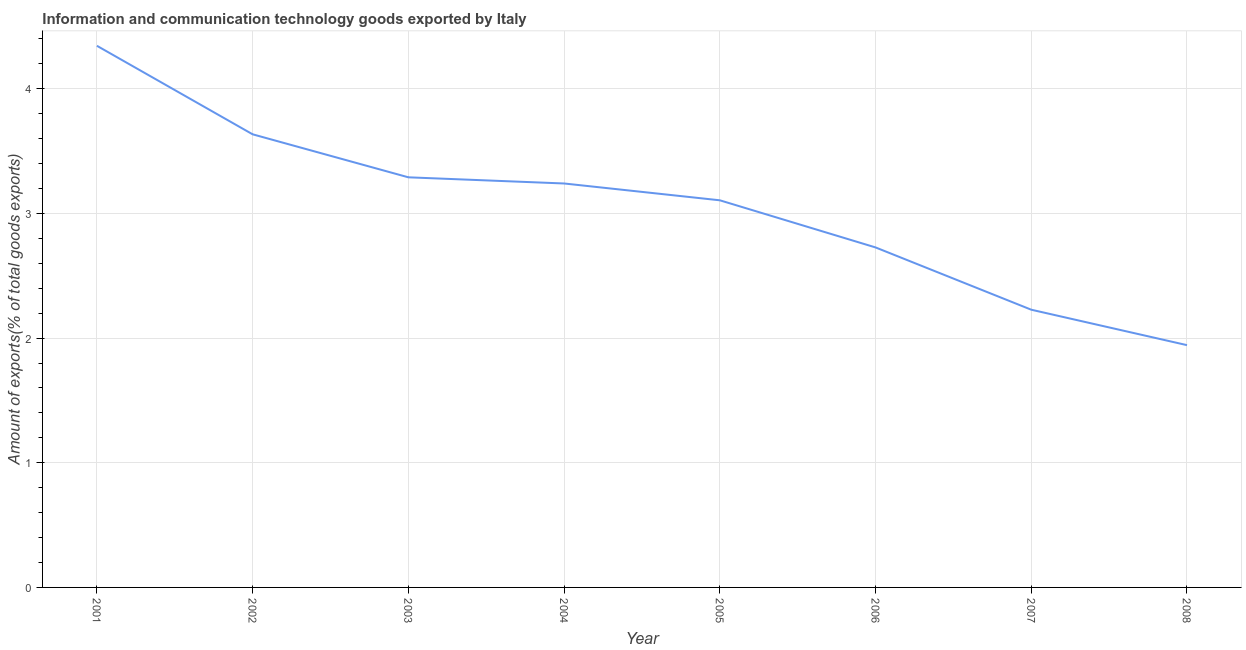What is the amount of ict goods exports in 2002?
Your answer should be very brief. 3.63. Across all years, what is the maximum amount of ict goods exports?
Your response must be concise. 4.34. Across all years, what is the minimum amount of ict goods exports?
Offer a very short reply. 1.94. In which year was the amount of ict goods exports minimum?
Offer a terse response. 2008. What is the sum of the amount of ict goods exports?
Offer a very short reply. 24.51. What is the difference between the amount of ict goods exports in 2003 and 2005?
Offer a very short reply. 0.18. What is the average amount of ict goods exports per year?
Ensure brevity in your answer.  3.06. What is the median amount of ict goods exports?
Keep it short and to the point. 3.17. What is the ratio of the amount of ict goods exports in 2005 to that in 2007?
Make the answer very short. 1.39. What is the difference between the highest and the second highest amount of ict goods exports?
Ensure brevity in your answer.  0.71. What is the difference between the highest and the lowest amount of ict goods exports?
Your answer should be compact. 2.4. In how many years, is the amount of ict goods exports greater than the average amount of ict goods exports taken over all years?
Make the answer very short. 5. How many lines are there?
Give a very brief answer. 1. How many years are there in the graph?
Your answer should be compact. 8. Does the graph contain any zero values?
Your answer should be very brief. No. What is the title of the graph?
Offer a very short reply. Information and communication technology goods exported by Italy. What is the label or title of the Y-axis?
Keep it short and to the point. Amount of exports(% of total goods exports). What is the Amount of exports(% of total goods exports) in 2001?
Keep it short and to the point. 4.34. What is the Amount of exports(% of total goods exports) in 2002?
Keep it short and to the point. 3.63. What is the Amount of exports(% of total goods exports) in 2003?
Offer a terse response. 3.29. What is the Amount of exports(% of total goods exports) in 2004?
Keep it short and to the point. 3.24. What is the Amount of exports(% of total goods exports) in 2005?
Ensure brevity in your answer.  3.11. What is the Amount of exports(% of total goods exports) of 2006?
Provide a short and direct response. 2.73. What is the Amount of exports(% of total goods exports) of 2007?
Provide a short and direct response. 2.23. What is the Amount of exports(% of total goods exports) in 2008?
Keep it short and to the point. 1.94. What is the difference between the Amount of exports(% of total goods exports) in 2001 and 2002?
Offer a terse response. 0.71. What is the difference between the Amount of exports(% of total goods exports) in 2001 and 2003?
Make the answer very short. 1.05. What is the difference between the Amount of exports(% of total goods exports) in 2001 and 2004?
Ensure brevity in your answer.  1.1. What is the difference between the Amount of exports(% of total goods exports) in 2001 and 2005?
Offer a terse response. 1.24. What is the difference between the Amount of exports(% of total goods exports) in 2001 and 2006?
Your answer should be compact. 1.62. What is the difference between the Amount of exports(% of total goods exports) in 2001 and 2007?
Offer a very short reply. 2.12. What is the difference between the Amount of exports(% of total goods exports) in 2001 and 2008?
Your answer should be very brief. 2.4. What is the difference between the Amount of exports(% of total goods exports) in 2002 and 2003?
Offer a terse response. 0.34. What is the difference between the Amount of exports(% of total goods exports) in 2002 and 2004?
Your answer should be compact. 0.39. What is the difference between the Amount of exports(% of total goods exports) in 2002 and 2005?
Offer a very short reply. 0.53. What is the difference between the Amount of exports(% of total goods exports) in 2002 and 2006?
Provide a short and direct response. 0.91. What is the difference between the Amount of exports(% of total goods exports) in 2002 and 2007?
Keep it short and to the point. 1.41. What is the difference between the Amount of exports(% of total goods exports) in 2002 and 2008?
Make the answer very short. 1.69. What is the difference between the Amount of exports(% of total goods exports) in 2003 and 2004?
Give a very brief answer. 0.05. What is the difference between the Amount of exports(% of total goods exports) in 2003 and 2005?
Ensure brevity in your answer.  0.18. What is the difference between the Amount of exports(% of total goods exports) in 2003 and 2006?
Your answer should be very brief. 0.56. What is the difference between the Amount of exports(% of total goods exports) in 2003 and 2007?
Provide a short and direct response. 1.06. What is the difference between the Amount of exports(% of total goods exports) in 2003 and 2008?
Your answer should be compact. 1.35. What is the difference between the Amount of exports(% of total goods exports) in 2004 and 2005?
Make the answer very short. 0.13. What is the difference between the Amount of exports(% of total goods exports) in 2004 and 2006?
Ensure brevity in your answer.  0.51. What is the difference between the Amount of exports(% of total goods exports) in 2004 and 2007?
Provide a succinct answer. 1.01. What is the difference between the Amount of exports(% of total goods exports) in 2004 and 2008?
Your response must be concise. 1.3. What is the difference between the Amount of exports(% of total goods exports) in 2005 and 2006?
Ensure brevity in your answer.  0.38. What is the difference between the Amount of exports(% of total goods exports) in 2005 and 2007?
Offer a terse response. 0.88. What is the difference between the Amount of exports(% of total goods exports) in 2005 and 2008?
Offer a terse response. 1.16. What is the difference between the Amount of exports(% of total goods exports) in 2006 and 2007?
Offer a very short reply. 0.5. What is the difference between the Amount of exports(% of total goods exports) in 2006 and 2008?
Provide a succinct answer. 0.78. What is the difference between the Amount of exports(% of total goods exports) in 2007 and 2008?
Offer a terse response. 0.28. What is the ratio of the Amount of exports(% of total goods exports) in 2001 to that in 2002?
Offer a terse response. 1.2. What is the ratio of the Amount of exports(% of total goods exports) in 2001 to that in 2003?
Make the answer very short. 1.32. What is the ratio of the Amount of exports(% of total goods exports) in 2001 to that in 2004?
Ensure brevity in your answer.  1.34. What is the ratio of the Amount of exports(% of total goods exports) in 2001 to that in 2005?
Your answer should be compact. 1.4. What is the ratio of the Amount of exports(% of total goods exports) in 2001 to that in 2006?
Offer a terse response. 1.59. What is the ratio of the Amount of exports(% of total goods exports) in 2001 to that in 2007?
Make the answer very short. 1.95. What is the ratio of the Amount of exports(% of total goods exports) in 2001 to that in 2008?
Ensure brevity in your answer.  2.24. What is the ratio of the Amount of exports(% of total goods exports) in 2002 to that in 2003?
Keep it short and to the point. 1.1. What is the ratio of the Amount of exports(% of total goods exports) in 2002 to that in 2004?
Make the answer very short. 1.12. What is the ratio of the Amount of exports(% of total goods exports) in 2002 to that in 2005?
Your answer should be very brief. 1.17. What is the ratio of the Amount of exports(% of total goods exports) in 2002 to that in 2006?
Offer a terse response. 1.33. What is the ratio of the Amount of exports(% of total goods exports) in 2002 to that in 2007?
Give a very brief answer. 1.63. What is the ratio of the Amount of exports(% of total goods exports) in 2002 to that in 2008?
Ensure brevity in your answer.  1.87. What is the ratio of the Amount of exports(% of total goods exports) in 2003 to that in 2005?
Provide a succinct answer. 1.06. What is the ratio of the Amount of exports(% of total goods exports) in 2003 to that in 2006?
Give a very brief answer. 1.21. What is the ratio of the Amount of exports(% of total goods exports) in 2003 to that in 2007?
Your answer should be very brief. 1.48. What is the ratio of the Amount of exports(% of total goods exports) in 2003 to that in 2008?
Give a very brief answer. 1.69. What is the ratio of the Amount of exports(% of total goods exports) in 2004 to that in 2005?
Ensure brevity in your answer.  1.04. What is the ratio of the Amount of exports(% of total goods exports) in 2004 to that in 2006?
Provide a succinct answer. 1.19. What is the ratio of the Amount of exports(% of total goods exports) in 2004 to that in 2007?
Offer a terse response. 1.46. What is the ratio of the Amount of exports(% of total goods exports) in 2004 to that in 2008?
Your answer should be very brief. 1.67. What is the ratio of the Amount of exports(% of total goods exports) in 2005 to that in 2006?
Make the answer very short. 1.14. What is the ratio of the Amount of exports(% of total goods exports) in 2005 to that in 2007?
Offer a terse response. 1.39. What is the ratio of the Amount of exports(% of total goods exports) in 2005 to that in 2008?
Provide a short and direct response. 1.6. What is the ratio of the Amount of exports(% of total goods exports) in 2006 to that in 2007?
Your answer should be very brief. 1.22. What is the ratio of the Amount of exports(% of total goods exports) in 2006 to that in 2008?
Provide a succinct answer. 1.4. What is the ratio of the Amount of exports(% of total goods exports) in 2007 to that in 2008?
Provide a succinct answer. 1.15. 